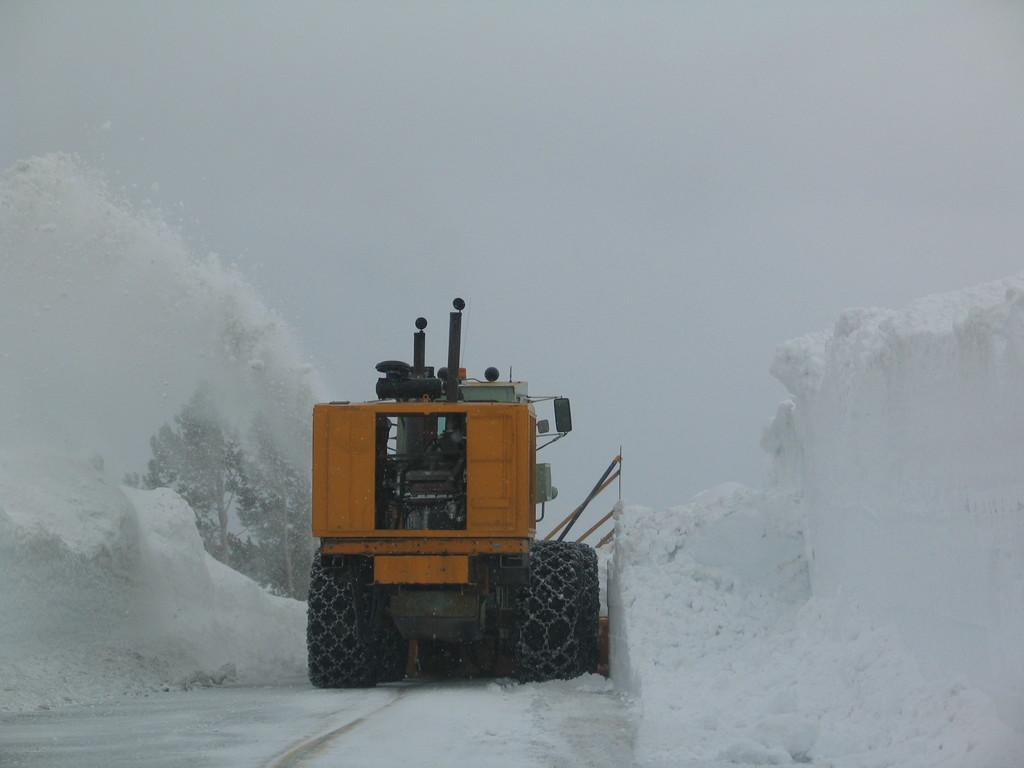What is the main object in the middle of the image? There is a machine in the middle of the image. What is the setting of the image? The machine is in the snow. What type of vegetation can be seen in the image? There are trees in the image. How are the trees affected by the snow? The trees are covered with snow. What is the overall color of the background in the image? The background of the image is white. What type of dinner is being served in the image? There is no dinner or any food present in the image; it features a machine in the snow with trees and a white background. Can you see an owl perched on one of the trees in the image? There is no owl present in the image; it only features a machine, snow, trees, and a white background. 